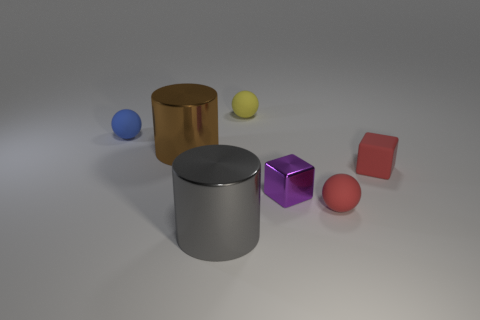Do the sphere in front of the small blue sphere and the block behind the small purple shiny object have the same material?
Give a very brief answer. Yes. The object that is the same color as the small matte block is what shape?
Offer a terse response. Sphere. What number of green objects are metallic cylinders or rubber things?
Offer a very short reply. 0. What is the size of the purple block?
Provide a short and direct response. Small. Are there more blue matte spheres in front of the red sphere than large purple matte things?
Provide a succinct answer. No. There is a purple object; what number of big gray cylinders are in front of it?
Your answer should be compact. 1. Are there any green metal cylinders that have the same size as the blue rubber thing?
Make the answer very short. No. There is another metal object that is the same shape as the big gray metal object; what color is it?
Your answer should be compact. Brown. There is a metallic object that is in front of the small purple block; is it the same size as the red matte thing that is behind the purple block?
Your response must be concise. No. Are there any big brown metal objects of the same shape as the yellow object?
Give a very brief answer. No. 